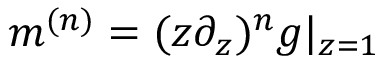Convert formula to latex. <formula><loc_0><loc_0><loc_500><loc_500>m ^ { ( n ) } = ( z \partial _ { z } ) ^ { n } g | _ { z = 1 }</formula> 